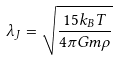Convert formula to latex. <formula><loc_0><loc_0><loc_500><loc_500>\lambda _ { J } = \sqrt { \frac { 1 5 k _ { B } T } { 4 \pi G m \rho } }</formula> 